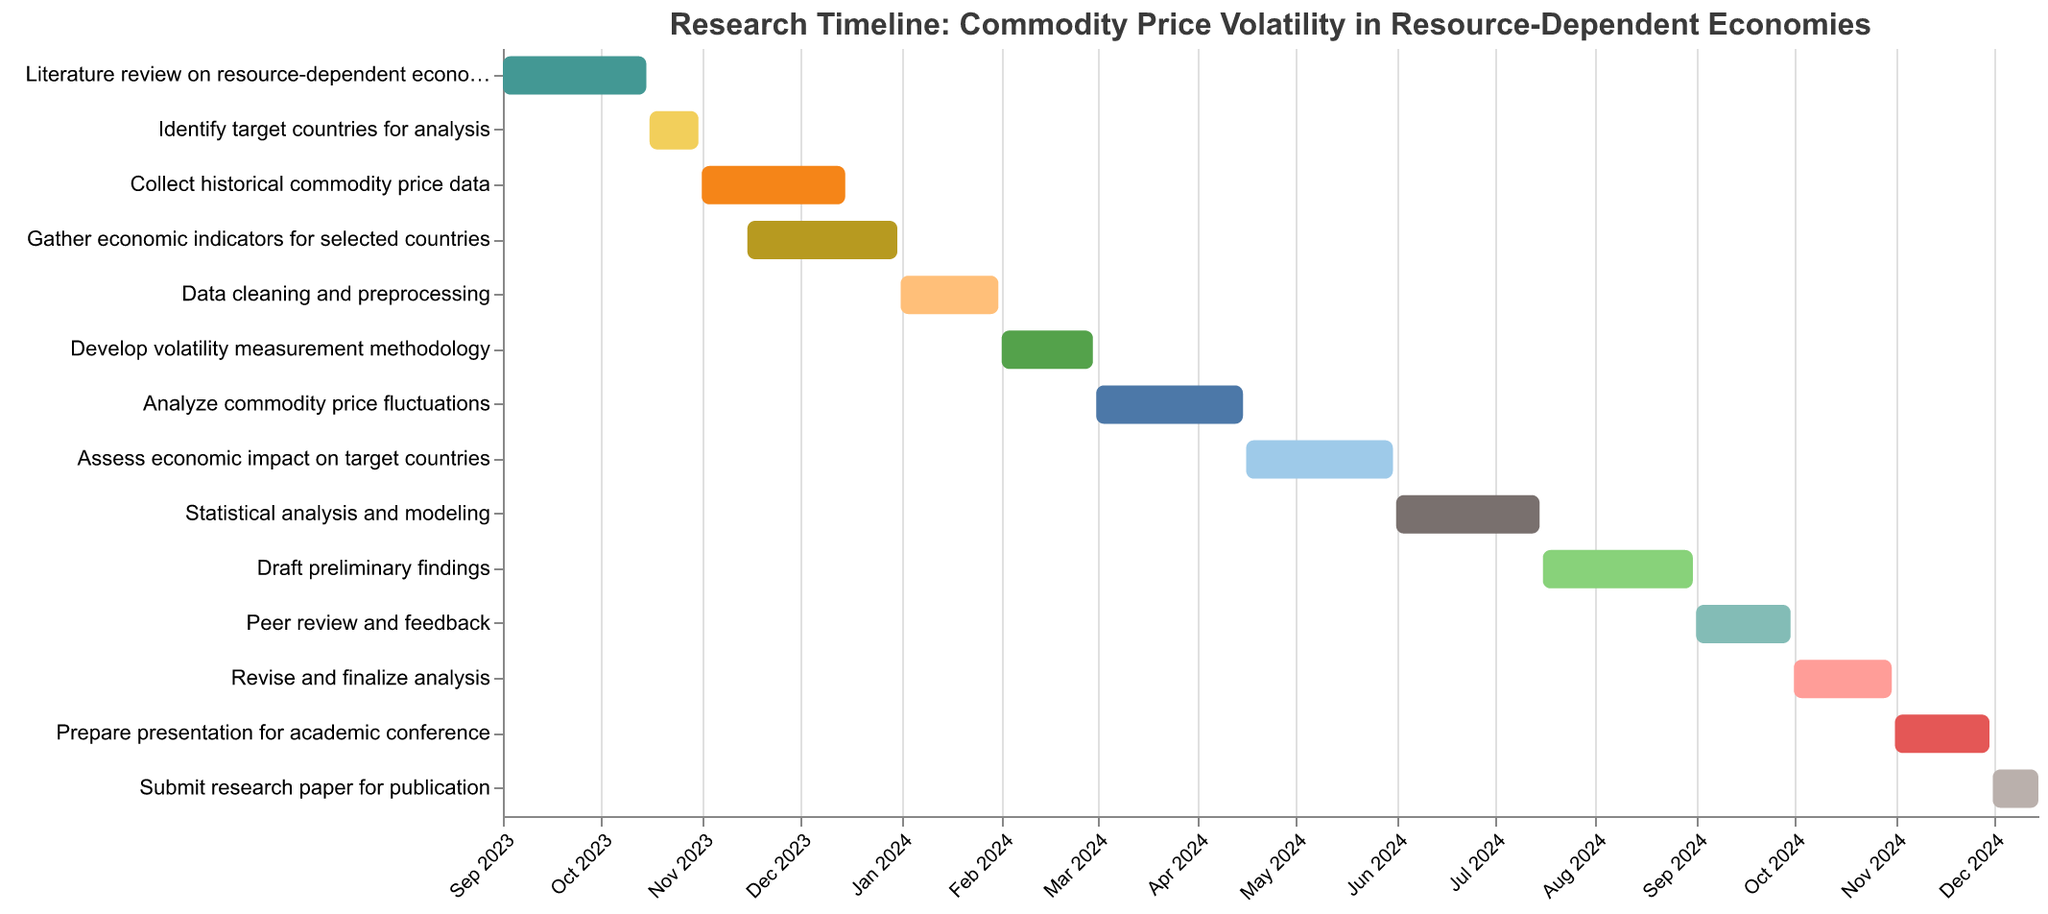What is the title of the Gantt Chart? The title of the Gantt Chart is displayed at the top of the figure, indicating the subject of the timeline.
Answer: Research Timeline: Commodity Price Volatility in Resource-Dependent Economies When does the task "Literature review on resource-dependent economies" start and end? The tooltip and the bars on the Gantt chart show the timeline for each task. The "Literature review" task starts on September 1, 2023, and ends on October 15, 2023.
Answer: September 1, 2023 to October 15, 2023 Which task takes place during both November and December 2023? By examining the dates on the x-axis and the bars that span those months, we find that the tasks “Collect historical commodity price data” (November 1 to December 15, 2023) and “Gather economic indicators for selected countries” (November 15 to December 31, 2023) both cover parts of November and December 2023.
Answer: Collect historical commodity price data and Gather economic indicators for selected countries How long does the task "Analyze commodity price fluctuations" last? We need to calculate the duration from the start date to the end date for this task. From March 1, 2024, to April 15, 2024, it spans 45 days (31 days in March + 14 days in April).
Answer: 45 days Are there any tasks that overlap in January 2024? If yes, which ones? By checking the bars that span January 2024, we see that “Data cleaning and preprocessing” (January 1 to January 31, 2024) overlaps completely within this month.
Answer: Data cleaning and preprocessing What is the task immediately following "Develop volatility measurement methodology"? The tasks are arranged sequentially along the y-axis. The task following "Develop volatility measurement methodology," which ends on February 29, 2024, is “Analyze commodity price fluctuations,” which starts on March 1, 2024.
Answer: Analyze commodity price fluctuations Which task has the shortest duration? Calculating the duration for each task by the provided start and end dates, we find that "Identify target countries for analysis" (October 16, 2023, to October 31, 2023) lasts only 15 days.
Answer: Identify target countries for analysis What is the overall duration of the entire project, from the start of the first task to the end of the last task? The project starts with "Literature review on resource-dependent economies" on September 1, 2023, and ends with "Submit research paper for publication" on December 15, 2024. From start to finish, it spans 15 months and 15 days.
Answer: 15 months and 15 days What tasks take place concurrently in April 2024? Looking at the bars for April 2024 on the x-axis, we find that "Analyze commodity price fluctuations” (March 1 to April 15, 2024) and "Assess economic impact on target countries" (April 16 to May 31, 2024) occur sequentially, not concurrently. Thus, only "Analyze commodity price fluctuations" spans partially into April 2024.
Answer: Analyze commodity price fluctuations Which task spends the most time in 2024? We look at the durations for tasks in 2024. "Assess economic impact on target countries" (April 16 to May 31, 2024), lasting for 46 days, extends more into 2024 than other tasks.
Answer: Assess economic impact on target countries 